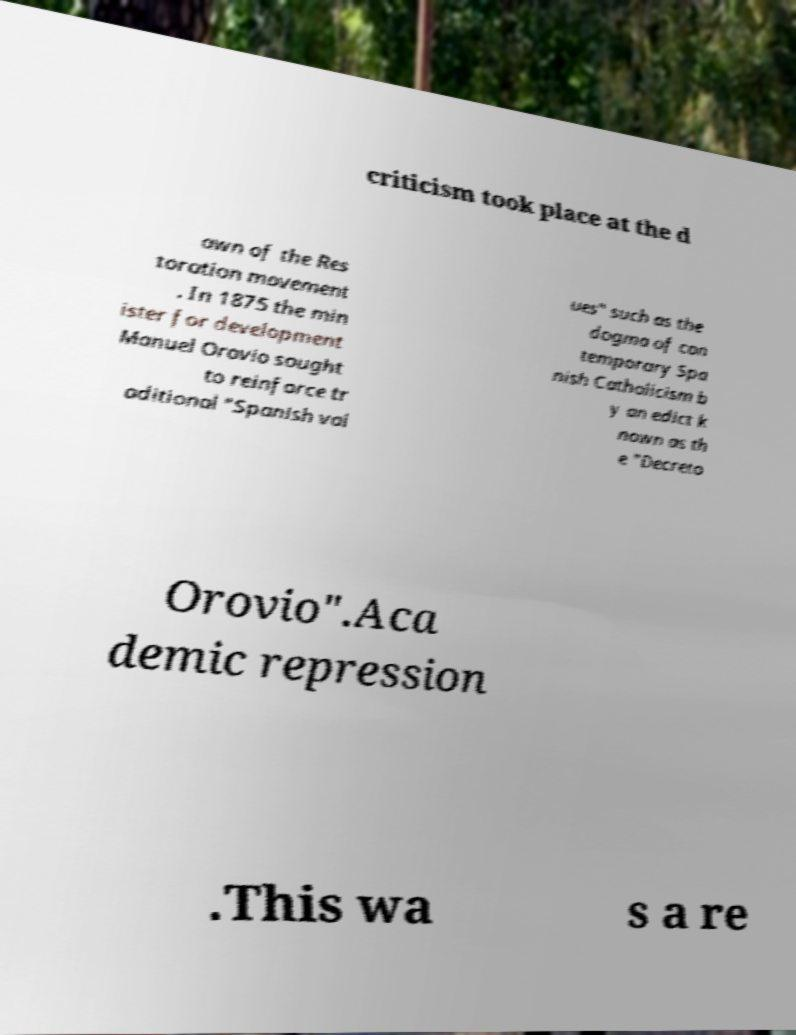Please read and relay the text visible in this image. What does it say? criticism took place at the d awn of the Res toration movement . In 1875 the min ister for development Manuel Orovio sought to reinforce tr aditional "Spanish val ues" such as the dogma of con temporary Spa nish Catholicism b y an edict k nown as th e "Decreto Orovio".Aca demic repression .This wa s a re 